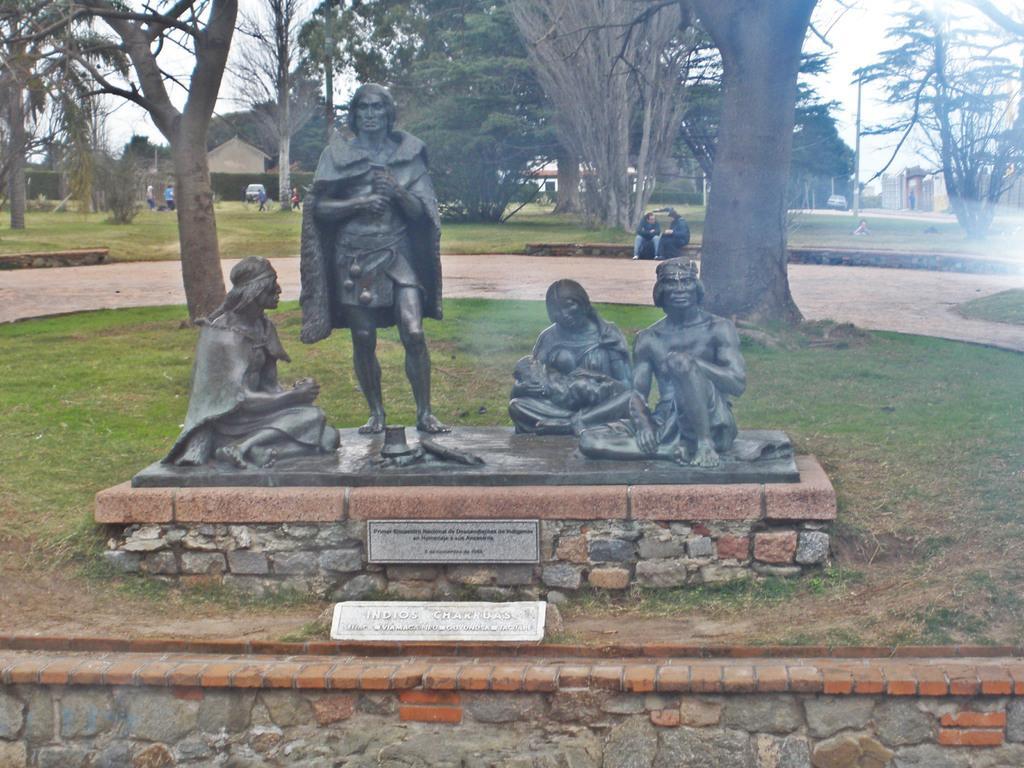In one or two sentences, can you explain what this image depicts? In this picture, we can see a few statues, name plates, ground with grass, trees, poles, a few people, buildings, and the sky. 